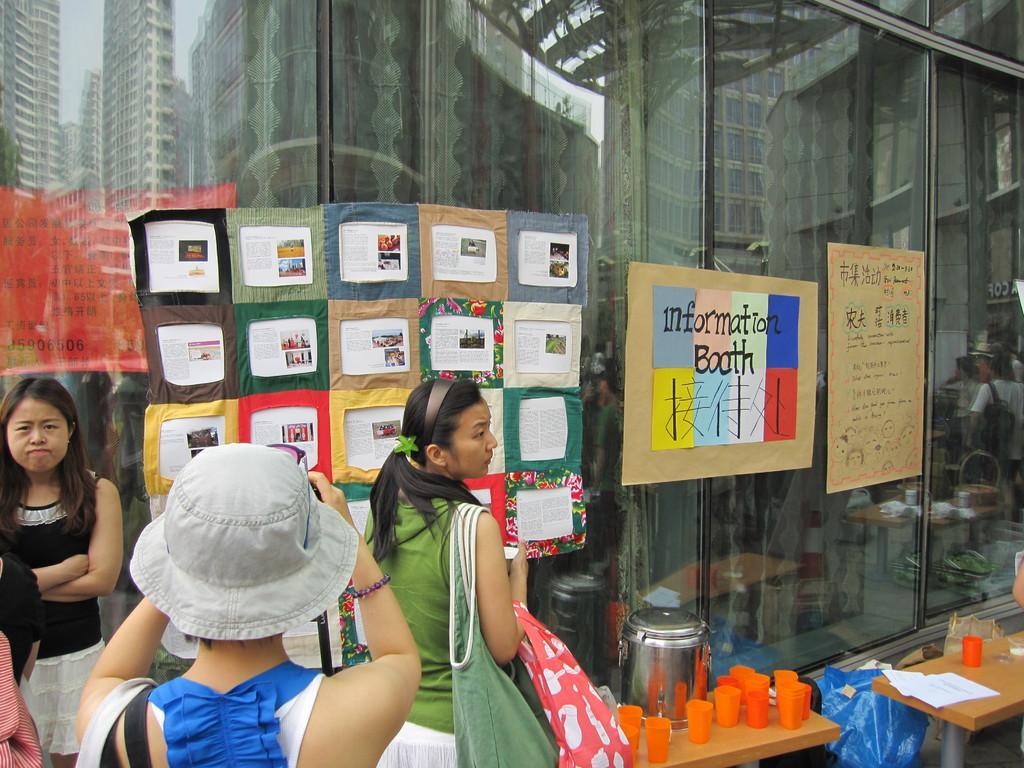In one or two sentences, can you explain what this image depicts? In this image I can see a group of women are standing. I can also see there are few tables with glasses and other objects on it. 